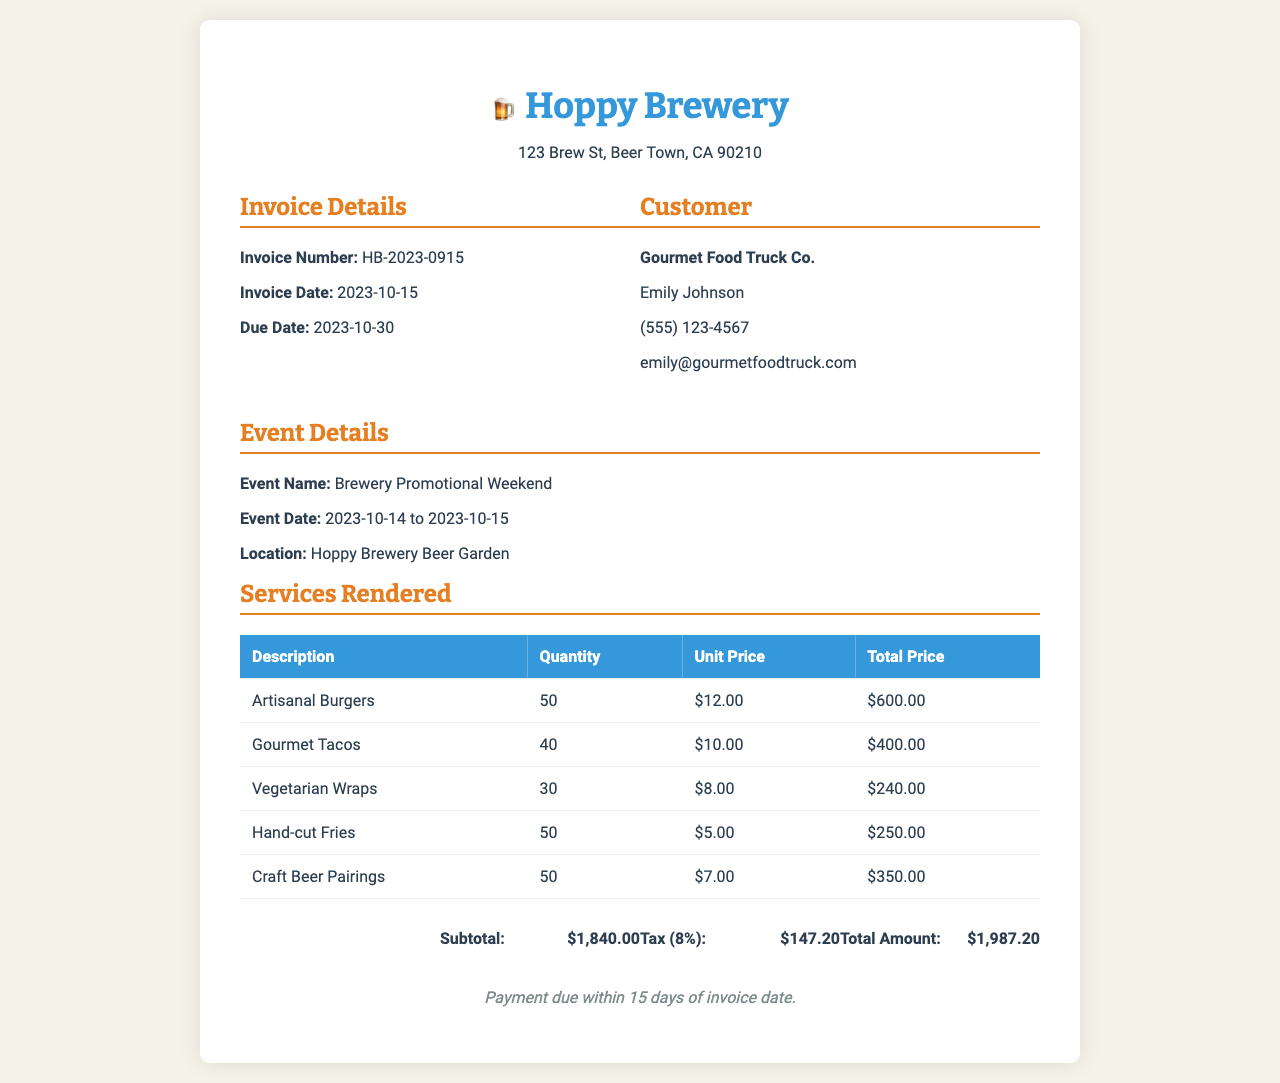What is the invoice number? The invoice number is specified near the top of the document under "Invoice Details."
Answer: HB-2023-0915 Who provided the catering services? The name of the company providing catering services is listed under the "Customer" section of the document.
Answer: Gourmet Food Truck Co What is the total amount due? The total amount is given at the end of the invoice under the "Total Amount" section.
Answer: $1,987.20 What is the event name? The event name is mentioned in the "Event Details" section of the document.
Answer: Brewery Promotional Weekend How many gourmet tacos were provided? The quantity of gourmet tacos can be found in the "Services Rendered" table in the document.
Answer: 40 What is the tax rate applied? The tax percentage is specified in the "total section" of the document.
Answer: 8% What is the due date for the invoice? The due date is listed in the "Invoice Details" section under the "Due Date" line.
Answer: 2023-10-30 What type of food items were provided at the event? The types of food items are detailed in the "Services Rendered" table, summarizing the offerings.
Answer: Artisanal Burgers, Gourmet Tacos, Vegetarian Wraps, Hand-cut Fries, Craft Beer Pairings How many vegetarian wraps were served? The quantity of vegetarian wraps can be found in the "Services Rendered" table of the document.
Answer: 30 